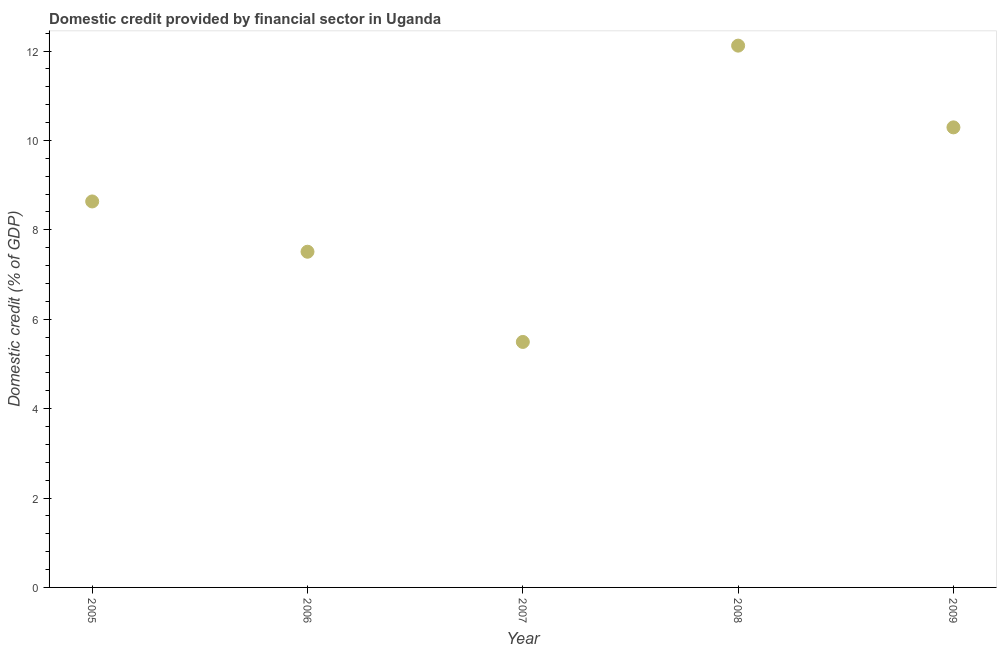What is the domestic credit provided by financial sector in 2008?
Your answer should be very brief. 12.12. Across all years, what is the maximum domestic credit provided by financial sector?
Provide a succinct answer. 12.12. Across all years, what is the minimum domestic credit provided by financial sector?
Your answer should be compact. 5.49. In which year was the domestic credit provided by financial sector minimum?
Your response must be concise. 2007. What is the sum of the domestic credit provided by financial sector?
Give a very brief answer. 44.05. What is the difference between the domestic credit provided by financial sector in 2007 and 2009?
Offer a very short reply. -4.8. What is the average domestic credit provided by financial sector per year?
Ensure brevity in your answer.  8.81. What is the median domestic credit provided by financial sector?
Provide a short and direct response. 8.64. Do a majority of the years between 2009 and 2006 (inclusive) have domestic credit provided by financial sector greater than 5.2 %?
Your answer should be compact. Yes. What is the ratio of the domestic credit provided by financial sector in 2006 to that in 2007?
Give a very brief answer. 1.37. Is the domestic credit provided by financial sector in 2008 less than that in 2009?
Keep it short and to the point. No. Is the difference between the domestic credit provided by financial sector in 2005 and 2008 greater than the difference between any two years?
Provide a succinct answer. No. What is the difference between the highest and the second highest domestic credit provided by financial sector?
Provide a short and direct response. 1.83. What is the difference between the highest and the lowest domestic credit provided by financial sector?
Offer a terse response. 6.63. How many years are there in the graph?
Ensure brevity in your answer.  5. What is the title of the graph?
Give a very brief answer. Domestic credit provided by financial sector in Uganda. What is the label or title of the X-axis?
Keep it short and to the point. Year. What is the label or title of the Y-axis?
Give a very brief answer. Domestic credit (% of GDP). What is the Domestic credit (% of GDP) in 2005?
Your response must be concise. 8.64. What is the Domestic credit (% of GDP) in 2006?
Your answer should be compact. 7.51. What is the Domestic credit (% of GDP) in 2007?
Your response must be concise. 5.49. What is the Domestic credit (% of GDP) in 2008?
Your response must be concise. 12.12. What is the Domestic credit (% of GDP) in 2009?
Offer a very short reply. 10.29. What is the difference between the Domestic credit (% of GDP) in 2005 and 2007?
Ensure brevity in your answer.  3.14. What is the difference between the Domestic credit (% of GDP) in 2005 and 2008?
Offer a terse response. -3.49. What is the difference between the Domestic credit (% of GDP) in 2005 and 2009?
Ensure brevity in your answer.  -1.66. What is the difference between the Domestic credit (% of GDP) in 2006 and 2007?
Provide a short and direct response. 2.02. What is the difference between the Domestic credit (% of GDP) in 2006 and 2008?
Offer a terse response. -4.61. What is the difference between the Domestic credit (% of GDP) in 2006 and 2009?
Offer a terse response. -2.78. What is the difference between the Domestic credit (% of GDP) in 2007 and 2008?
Provide a succinct answer. -6.63. What is the difference between the Domestic credit (% of GDP) in 2007 and 2009?
Provide a succinct answer. -4.8. What is the difference between the Domestic credit (% of GDP) in 2008 and 2009?
Your answer should be very brief. 1.83. What is the ratio of the Domestic credit (% of GDP) in 2005 to that in 2006?
Give a very brief answer. 1.15. What is the ratio of the Domestic credit (% of GDP) in 2005 to that in 2007?
Keep it short and to the point. 1.57. What is the ratio of the Domestic credit (% of GDP) in 2005 to that in 2008?
Your response must be concise. 0.71. What is the ratio of the Domestic credit (% of GDP) in 2005 to that in 2009?
Your response must be concise. 0.84. What is the ratio of the Domestic credit (% of GDP) in 2006 to that in 2007?
Give a very brief answer. 1.37. What is the ratio of the Domestic credit (% of GDP) in 2006 to that in 2008?
Provide a short and direct response. 0.62. What is the ratio of the Domestic credit (% of GDP) in 2006 to that in 2009?
Keep it short and to the point. 0.73. What is the ratio of the Domestic credit (% of GDP) in 2007 to that in 2008?
Provide a succinct answer. 0.45. What is the ratio of the Domestic credit (% of GDP) in 2007 to that in 2009?
Provide a succinct answer. 0.53. What is the ratio of the Domestic credit (% of GDP) in 2008 to that in 2009?
Your answer should be compact. 1.18. 